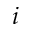Convert formula to latex. <formula><loc_0><loc_0><loc_500><loc_500>i</formula> 